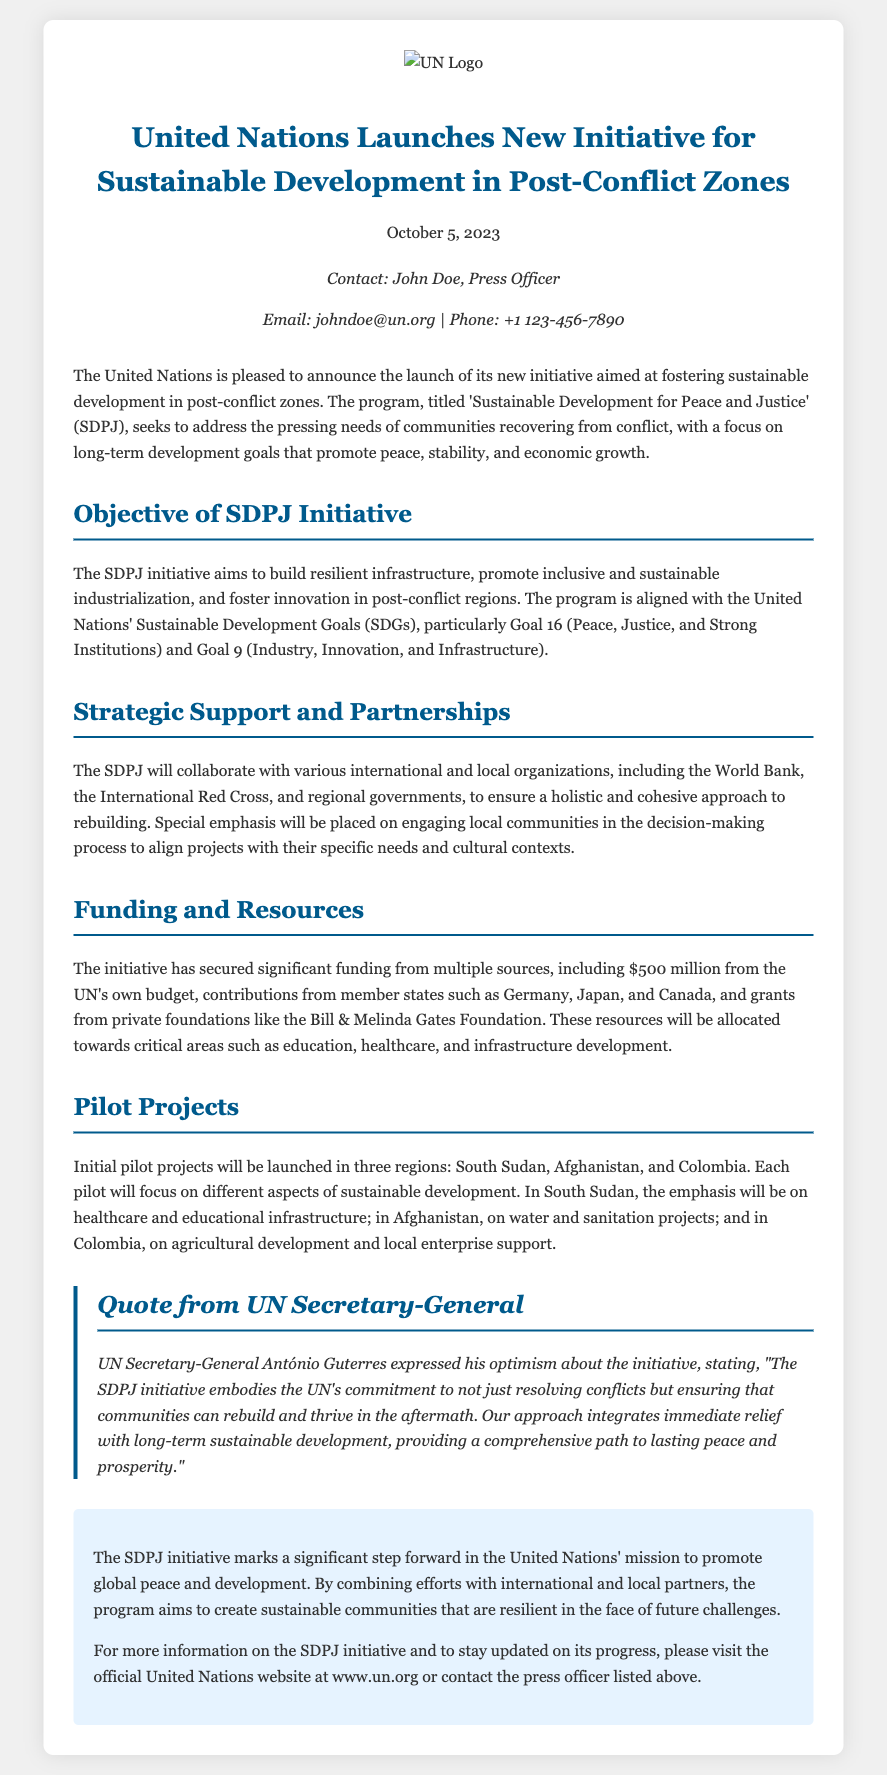What is the name of the initiative launched by the UN? The initiative is named 'Sustainable Development for Peace and Justice' (SDPJ).
Answer: SDPJ When was the initiative launched? The initiative was launched on October 5, 2023.
Answer: October 5, 2023 How much funding has the initiative secured from the UN's budget? The initiative has secured $500 million from the UN's own budget.
Answer: $500 million Which three countries will have pilot projects? The pilot projects will be launched in South Sudan, Afghanistan, and Colombia.
Answer: South Sudan, Afghanistan, and Colombia Who expressed optimism about the initiative? UN Secretary-General António Guterres expressed optimism about the initiative.
Answer: António Guterres What goal is emphasized in the SDPJ initiative? Goal 16 (Peace, Justice, and Strong Institutions) is emphasized in the SDPJ initiative.
Answer: Goal 16 What is the main focus of the pilot project in South Sudan? The main focus of the pilot project in South Sudan is on healthcare and educational infrastructure.
Answer: Healthcare and educational infrastructure Which foundation is mentioned as a contributor to the initiative? The Bill & Melinda Gates Foundation is mentioned as a contributor.
Answer: Bill & Melinda Gates Foundation What is the overarching aim of the SDPJ initiative? The overarching aim of the SDPJ initiative is to foster sustainable development in post-conflict zones.
Answer: Foster sustainable development in post-conflict zones 